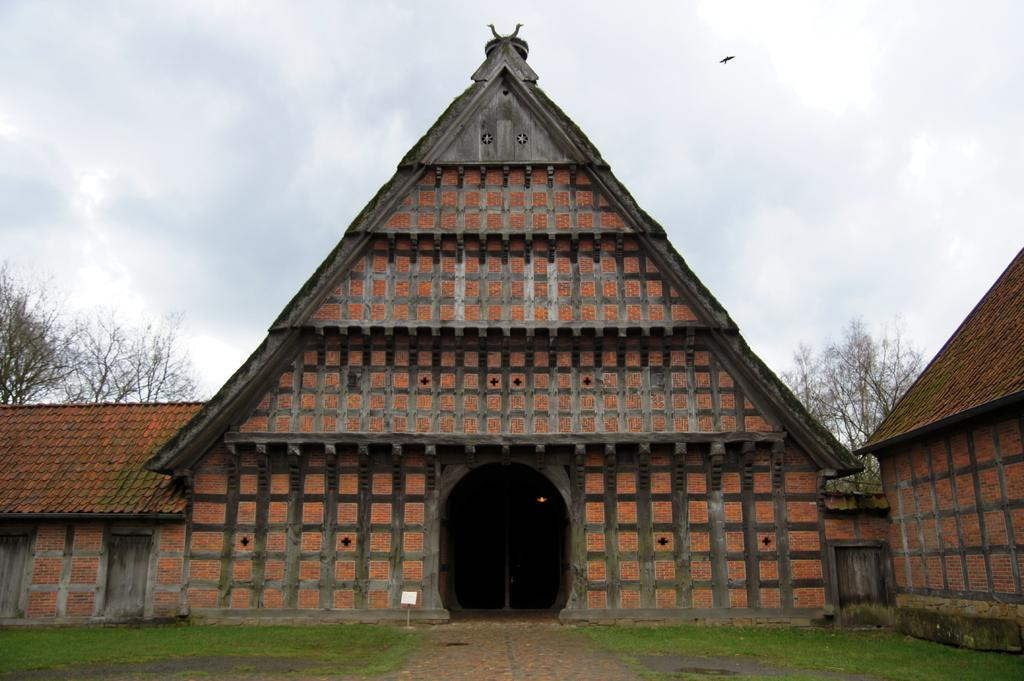What type of structure is in the image? There is a house in the image. What part of the natural environment is visible in the image? The sky is visible in the image. What animal can be seen in the image? A bird is present in the image. What is the bird doing in the image? The bird is flying in the air. What type of vegetation is visible behind the house? Trees are visible behind the house. How many legs can be seen on the branch in the image? There is no branch present in the image, and therefore no legs can be seen on it. 